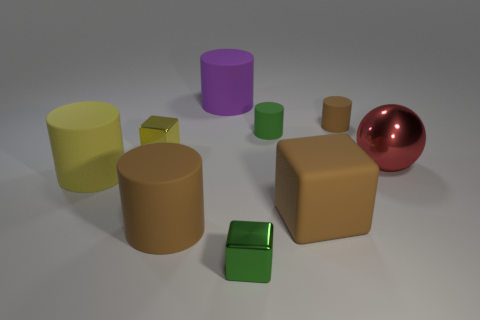Subtract all large yellow cylinders. How many cylinders are left? 4 Subtract all green cylinders. How many cylinders are left? 4 Subtract 1 cylinders. How many cylinders are left? 4 Subtract all red spheres. How many brown cylinders are left? 2 Add 1 brown cylinders. How many brown cylinders are left? 3 Add 3 small shiny blocks. How many small shiny blocks exist? 5 Subtract 0 green balls. How many objects are left? 9 Subtract all blocks. How many objects are left? 6 Subtract all purple cylinders. Subtract all red spheres. How many cylinders are left? 4 Subtract all big brown matte cubes. Subtract all small green metal things. How many objects are left? 7 